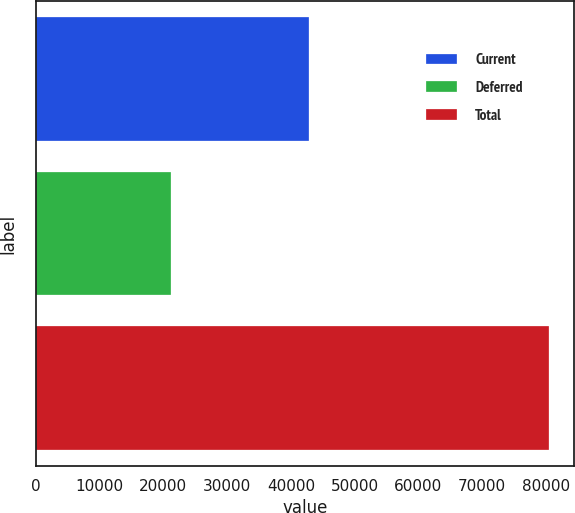Convert chart. <chart><loc_0><loc_0><loc_500><loc_500><bar_chart><fcel>Current<fcel>Deferred<fcel>Total<nl><fcel>42850<fcel>21153<fcel>80431<nl></chart> 